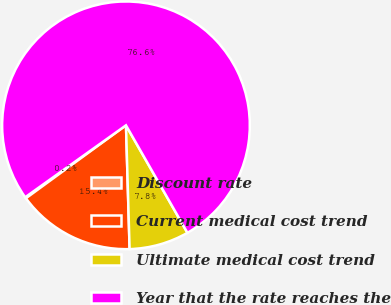Convert chart to OTSL. <chart><loc_0><loc_0><loc_500><loc_500><pie_chart><fcel>Discount rate<fcel>Current medical cost trend<fcel>Ultimate medical cost trend<fcel>Year that the rate reaches the<nl><fcel>0.16%<fcel>15.44%<fcel>7.8%<fcel>76.6%<nl></chart> 